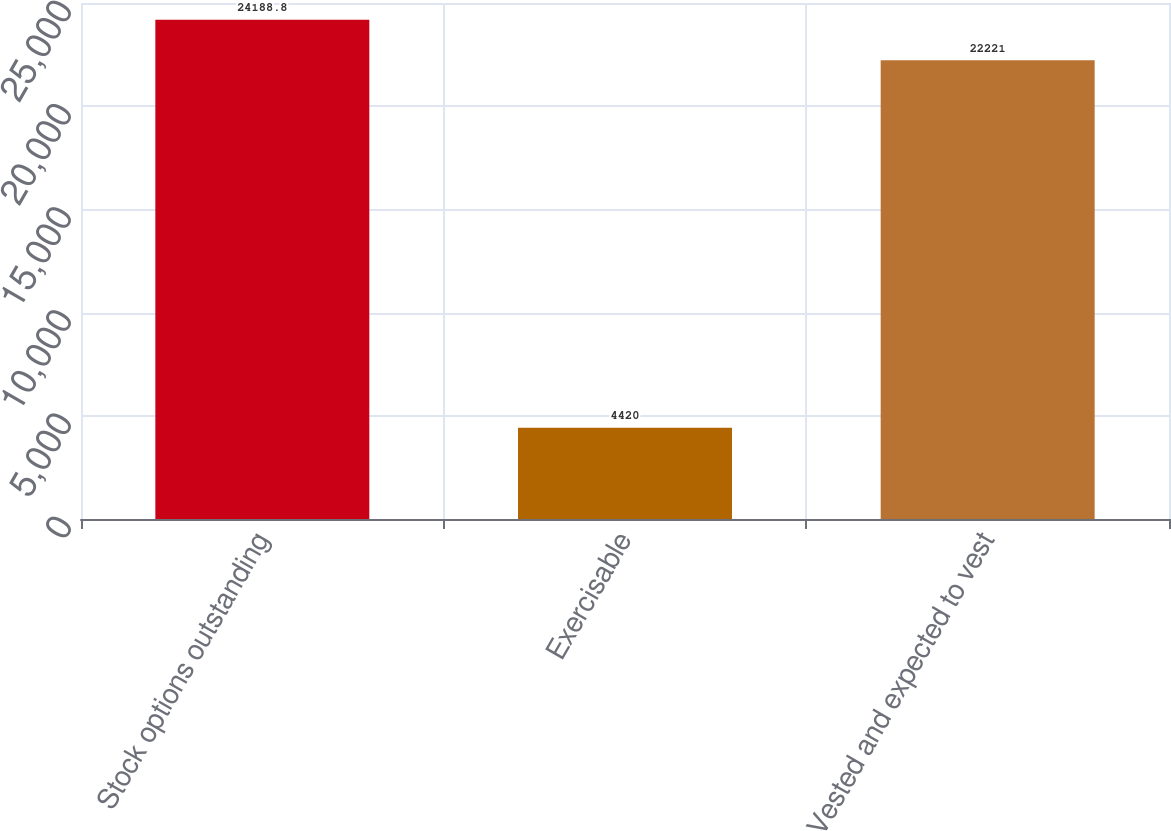Convert chart. <chart><loc_0><loc_0><loc_500><loc_500><bar_chart><fcel>Stock options outstanding<fcel>Exercisable<fcel>Vested and expected to vest<nl><fcel>24188.8<fcel>4420<fcel>22221<nl></chart> 